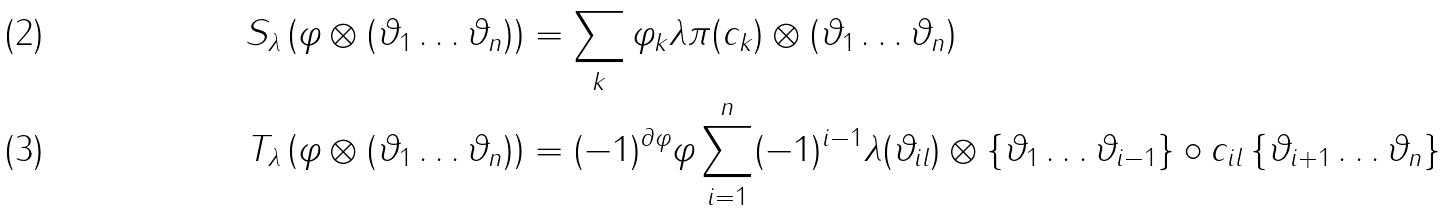<formula> <loc_0><loc_0><loc_500><loc_500>S _ { \lambda } \left ( \varphi \otimes ( \vartheta _ { 1 } \dots \vartheta _ { n } ) \right ) & = \sum _ { k } \varphi _ { k } \lambda \pi ( c _ { k } ) \otimes ( \vartheta _ { 1 } \dots \vartheta _ { n } ) \\ T _ { \lambda } \left ( \varphi \otimes ( \vartheta _ { 1 } \dots \vartheta _ { n } ) \right ) & = ( - 1 ) ^ { \partial \varphi } \varphi \sum _ { i = 1 } ^ { n } ( - 1 ) ^ { i - 1 } \lambda ( \vartheta _ { i l } ) \otimes \left \{ \vartheta _ { 1 } \dots \vartheta _ { i - 1 } \right \} \circ c _ { i l } \left \{ \vartheta _ { i + 1 } \dots \vartheta _ { n } \right \}</formula> 